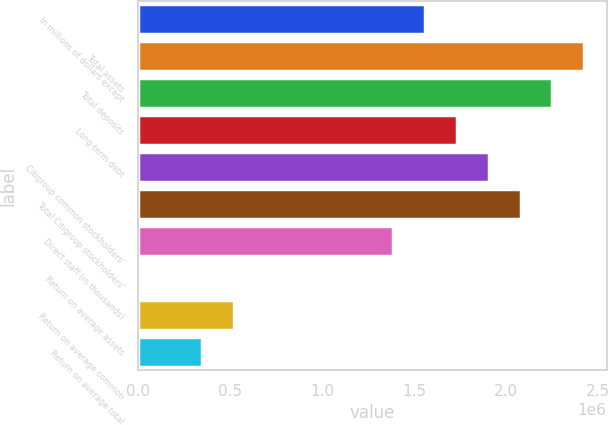Convert chart. <chart><loc_0><loc_0><loc_500><loc_500><bar_chart><fcel>In millions of dollars except<fcel>Total assets<fcel>Total deposits<fcel>Long-term debt<fcel>Citigroup common stockholders'<fcel>Total Citigroup stockholders'<fcel>Direct staff (in thousands)<fcel>Return on average assets<fcel>Return on average common<fcel>Return on average total<nl><fcel>1.55809e+06<fcel>2.42369e+06<fcel>2.25057e+06<fcel>1.73121e+06<fcel>1.90433e+06<fcel>2.07745e+06<fcel>1.38497e+06<fcel>0.95<fcel>519364<fcel>346243<nl></chart> 